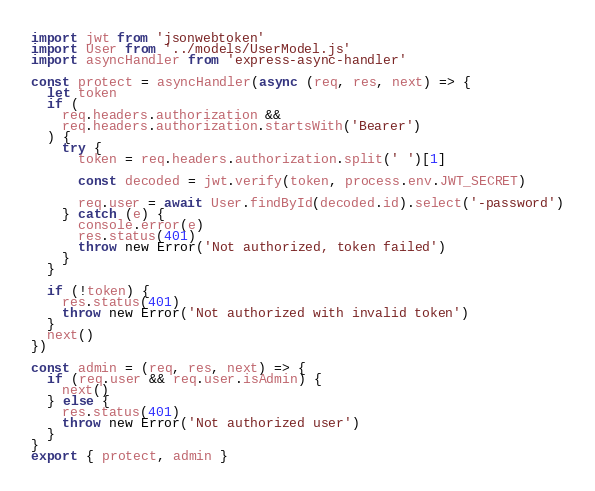<code> <loc_0><loc_0><loc_500><loc_500><_JavaScript_>import jwt from 'jsonwebtoken'
import User from '../models/UserModel.js'
import asyncHandler from 'express-async-handler'

const protect = asyncHandler(async (req, res, next) => {
  let token
  if (
    req.headers.authorization &&
    req.headers.authorization.startsWith('Bearer')
  ) {
    try {
      token = req.headers.authorization.split(' ')[1]

      const decoded = jwt.verify(token, process.env.JWT_SECRET)

      req.user = await User.findById(decoded.id).select('-password')
    } catch (e) {
      console.error(e)
      res.status(401)
      throw new Error('Not authorized, token failed')
    }
  }

  if (!token) {
    res.status(401)
    throw new Error('Not authorized with invalid token')
  }
  next()
})

const admin = (req, res, next) => {
  if (req.user && req.user.isAdmin) {
    next()
  } else {
    res.status(401)
    throw new Error('Not authorized user')
  }
}
export { protect, admin }
</code> 